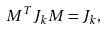Convert formula to latex. <formula><loc_0><loc_0><loc_500><loc_500>M ^ { T } J _ { k } M = J _ { k } ,</formula> 